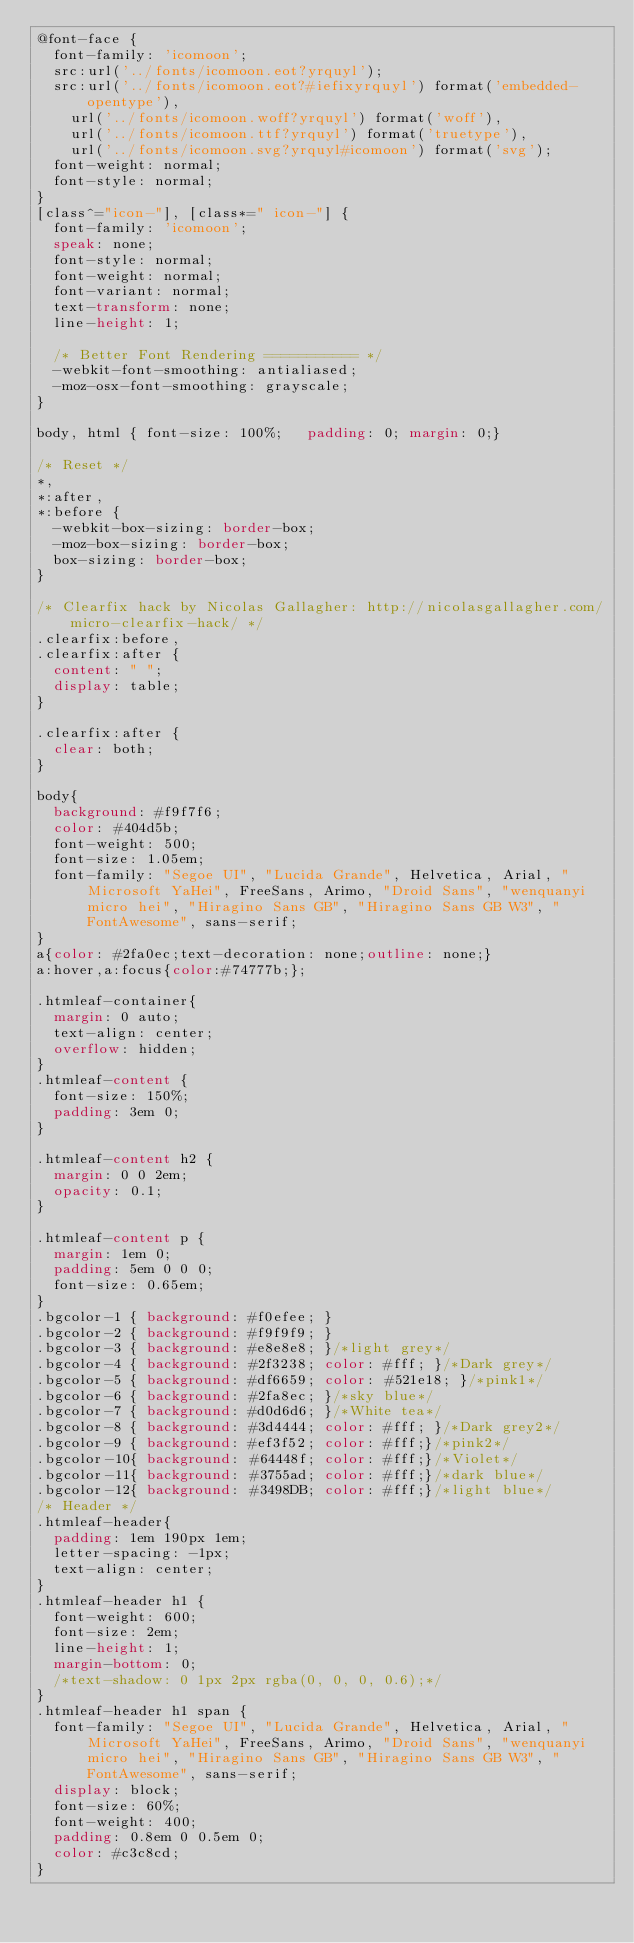<code> <loc_0><loc_0><loc_500><loc_500><_CSS_>@font-face {
	font-family: 'icomoon';
	src:url('../fonts/icomoon.eot?yrquyl');
	src:url('../fonts/icomoon.eot?#iefixyrquyl') format('embedded-opentype'),
		url('../fonts/icomoon.woff?yrquyl') format('woff'),
		url('../fonts/icomoon.ttf?yrquyl') format('truetype'),
		url('../fonts/icomoon.svg?yrquyl#icomoon') format('svg');
	font-weight: normal;
	font-style: normal;
}
[class^="icon-"], [class*=" icon-"] {
	font-family: 'icomoon';
	speak: none;
	font-style: normal;
	font-weight: normal;
	font-variant: normal;
	text-transform: none;
	line-height: 1;

	/* Better Font Rendering =========== */
	-webkit-font-smoothing: antialiased;
	-moz-osx-font-smoothing: grayscale;
}

body, html { font-size: 100%; 	padding: 0; margin: 0;}

/* Reset */
*,
*:after,
*:before {
	-webkit-box-sizing: border-box;
	-moz-box-sizing: border-box;
	box-sizing: border-box;
}

/* Clearfix hack by Nicolas Gallagher: http://nicolasgallagher.com/micro-clearfix-hack/ */
.clearfix:before,
.clearfix:after {
	content: " ";
	display: table;
}

.clearfix:after {
	clear: both;
}

body{
	background: #f9f7f6;
	color: #404d5b;
	font-weight: 500;
	font-size: 1.05em;
	font-family: "Segoe UI", "Lucida Grande", Helvetica, Arial, "Microsoft YaHei", FreeSans, Arimo, "Droid Sans", "wenquanyi micro hei", "Hiragino Sans GB", "Hiragino Sans GB W3", "FontAwesome", sans-serif;
}
a{color: #2fa0ec;text-decoration: none;outline: none;}
a:hover,a:focus{color:#74777b;};

.htmleaf-container{
	margin: 0 auto;
	text-align: center;
	overflow: hidden;
}
.htmleaf-content {
	font-size: 150%;
	padding: 3em 0;
}

.htmleaf-content h2 {
	margin: 0 0 2em;
	opacity: 0.1;
}

.htmleaf-content p {
	margin: 1em 0;
	padding: 5em 0 0 0;
	font-size: 0.65em;
}
.bgcolor-1 { background: #f0efee; }
.bgcolor-2 { background: #f9f9f9; }
.bgcolor-3 { background: #e8e8e8; }/*light grey*/
.bgcolor-4 { background: #2f3238; color: #fff; }/*Dark grey*/
.bgcolor-5 { background: #df6659; color: #521e18; }/*pink1*/
.bgcolor-6 { background: #2fa8ec; }/*sky blue*/
.bgcolor-7 { background: #d0d6d6; }/*White tea*/
.bgcolor-8 { background: #3d4444; color: #fff; }/*Dark grey2*/
.bgcolor-9 { background: #ef3f52; color: #fff;}/*pink2*/
.bgcolor-10{ background: #64448f; color: #fff;}/*Violet*/
.bgcolor-11{ background: #3755ad; color: #fff;}/*dark blue*/
.bgcolor-12{ background: #3498DB; color: #fff;}/*light blue*/
/* Header */
.htmleaf-header{
	padding: 1em 190px 1em;
	letter-spacing: -1px;
	text-align: center;
}
.htmleaf-header h1 {
	font-weight: 600;
	font-size: 2em;
	line-height: 1;
	margin-bottom: 0;
	/*text-shadow: 0 1px 2px rgba(0, 0, 0, 0.6);*/
}
.htmleaf-header h1 span {
	font-family: "Segoe UI", "Lucida Grande", Helvetica, Arial, "Microsoft YaHei", FreeSans, Arimo, "Droid Sans", "wenquanyi micro hei", "Hiragino Sans GB", "Hiragino Sans GB W3", "FontAwesome", sans-serif;
	display: block;
	font-size: 60%;
	font-weight: 400;
	padding: 0.8em 0 0.5em 0;
	color: #c3c8cd;
}</code> 